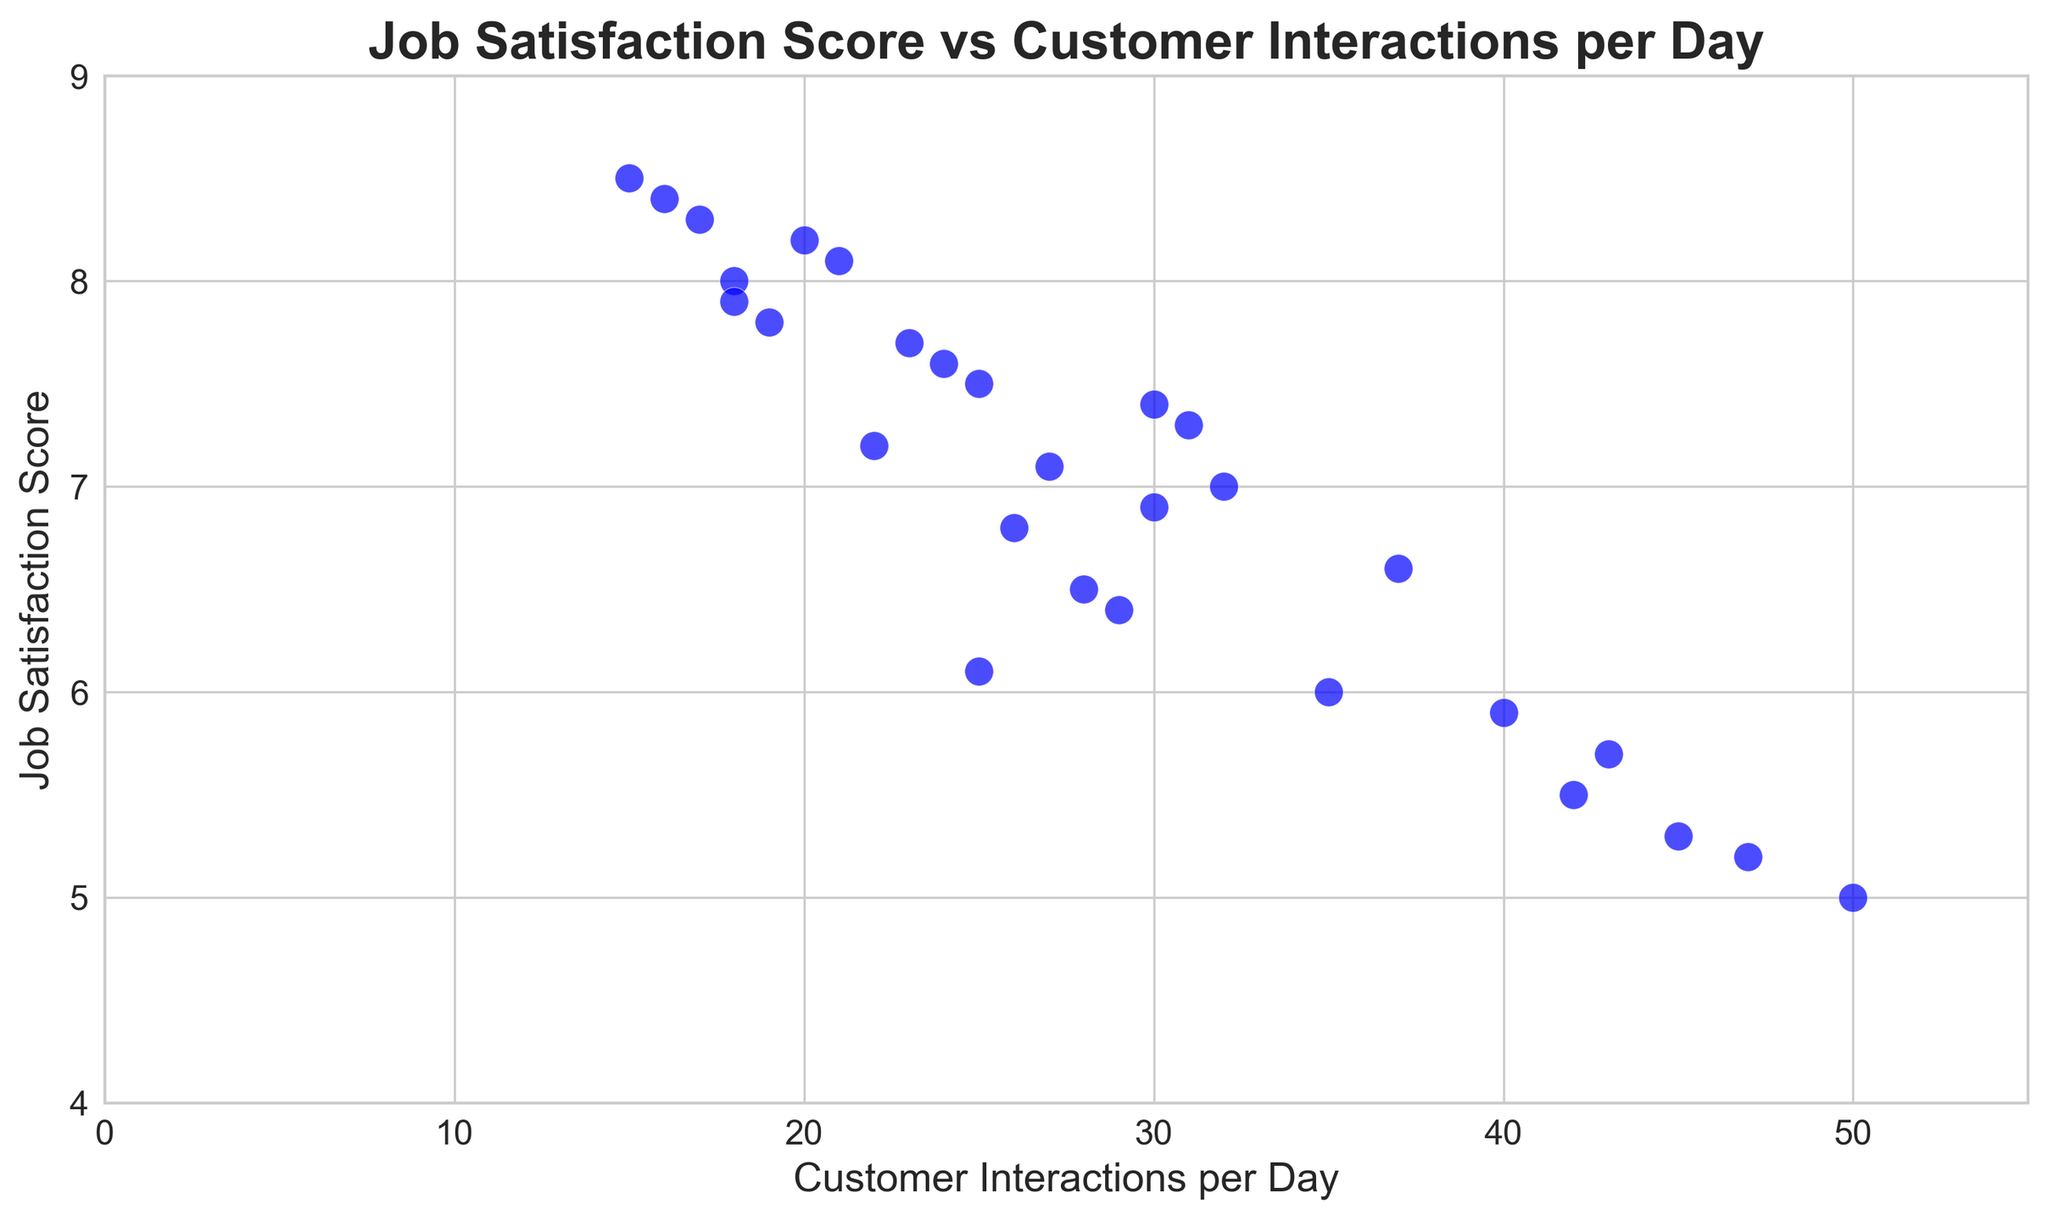How many shop assistants have a Job Satisfaction Score of 8.0 or above? First, locate all the points in the scatter plot with a job satisfaction score of 8.0 or higher. Then, count these points. From the plot, we see points with satisfaction scores of 8.0, 8.1, 8.2, 8.3, 8.4, and 8.5. These make up 6 shop assistants.
Answer: 6 What is the average Job Satisfaction Score for shop assistants interacting with more than 35 customers per day? Identify all points in the scatter plot for interactions greater than 35. These points are associated with satisfaction scores of 5.3, 5.9, 5.0, 5.5, 5.2, and 6.6. Sum these scores (5.3 + 5.9 + 5.0 + 5.5 + 5.2 + 6.6) = 33.5 and divide by the number of points (6). So, the average score is 33.5 / 6 = 5.58.
Answer: 5.58 Is there a visible correlation between Customer Interactions per Day and Job Satisfaction Scores, and if so, what type is it? Observe the general trend in the scatter plot. There is a slight downward trend, meaning that as customer interactions increase, the job satisfaction score tends to decrease. This indicates a negative correlation.
Answer: Negative Which shop assistant(s) have the lowest Job Satisfaction Score, and how many customers do they interact with per day? Locate the point with the lowest Satisfaction Score on the y-axis, which is 5.0. This point corresponds to 50 customer interactions per day.
Answer: 50 customers Do shop assistants with fewer than 20 customer interactions per day generally have higher or lower Job Satisfaction Scores? Identify points with fewer than 20 interactions per day. These points have scores of 8.5, 8.0, 7.8, 8.2, 8.3, 8.1, and 7.9. All these scores are relatively high, indicating higher satisfaction among these shop assistants.
Answer: Higher Which customer interaction range has the most points, and what does this suggest about the workload? Visually count the clusters of points in various ranges. The range of 20-30 interactions per day appears to have the most points. This suggests a common workload range among shop assistants.
Answer: 20-30 interactions per day What is the median Job Satisfaction Score for all shop assistants? First, list all scores in ascending order: 5.0, 5.2, 5.3, 5.5, 5.7, 5.9, 6.0, 6.1, 6.4, 6.5, 6.6, 6.8, 6.9, 7.0, 7.1, 7.2, 7.3, 7.4, 7.5, 7.6, 7.7, 7.8, 7.9, 8.0, 8.1, 8.2, 8.3, 8.4, 8.5. The median score is the middle value in this ordered list, which is the 15th value: 7.0.
Answer: 7.0 Compare the Job Satisfaction Scores for shop assistants who interact with 25 customers per day to those who interact with 30 customers per day. Locate the points for 25 and 30 interactions per day. For 25 interactions, the scores are 6.1 and 7.6 (average 6.85). For 30 interactions, the scores are 7.4 and 6.9 (average 7.15). Comparing these averages shows that satisfaction is slightly higher for assistants with 30 interactions.
Answer: Higher for 30 interactions Are there any outliers in terms of Job Satisfaction Scores, and what are their corresponding customer interactions per day? An outlier here would be a point far removed from others. The lowest and highest satisfaction scores can be considered outliers: 5.0 (50 interactions) and 8.5 (15 interactions). From the scatter plot, these points are considerably distant from the others.
Answer: 50 (5.0 score) and 15 (8.5 score) 